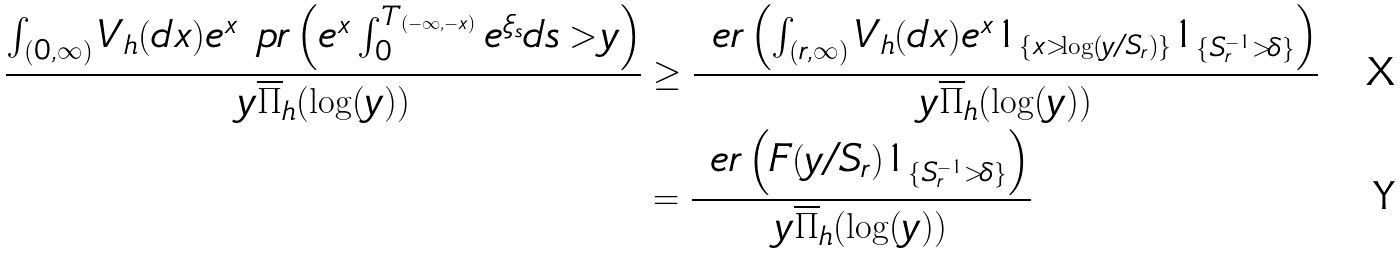<formula> <loc_0><loc_0><loc_500><loc_500>\frac { \int _ { ( 0 , \infty ) } V _ { h } ( d x ) e ^ { x } \ p r \left ( e ^ { x } \int ^ { T _ { ( - \infty , - x ) } } _ { 0 } e ^ { \xi _ { s } } d s > y \right ) } { y \overline { \Pi } _ { h } ( \log ( y ) ) } & \geq \frac { \ e r \left ( \int _ { ( r , \infty ) } V _ { h } ( d x ) e ^ { x } 1 _ { \left \{ x > \log \left ( y / S _ { r } \right ) \right \} } 1 _ { \{ S ^ { - 1 } _ { r } > \delta \} } \right ) } { y \overline { \Pi } _ { h } ( \log ( y ) ) } \\ & = \frac { \ e r \left ( F ( y / S _ { r } ) 1 _ { \{ S ^ { - 1 } _ { r } > \delta \} } \right ) } { y \overline { \Pi } _ { h } ( \log ( y ) ) }</formula> 